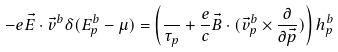Convert formula to latex. <formula><loc_0><loc_0><loc_500><loc_500>- e { \vec { E } } \cdot { \vec { v } } ^ { b } \delta ( E ^ { b } _ { p } - \mu ) = \left ( \frac { } { \tau _ { p } } + \frac { e } { c } { \vec { B } } \cdot ( { \vec { v } } ^ { b } _ { p } \times \frac { \partial } { \partial { \vec { p } } } ) \right ) h ^ { b } _ { p }</formula> 